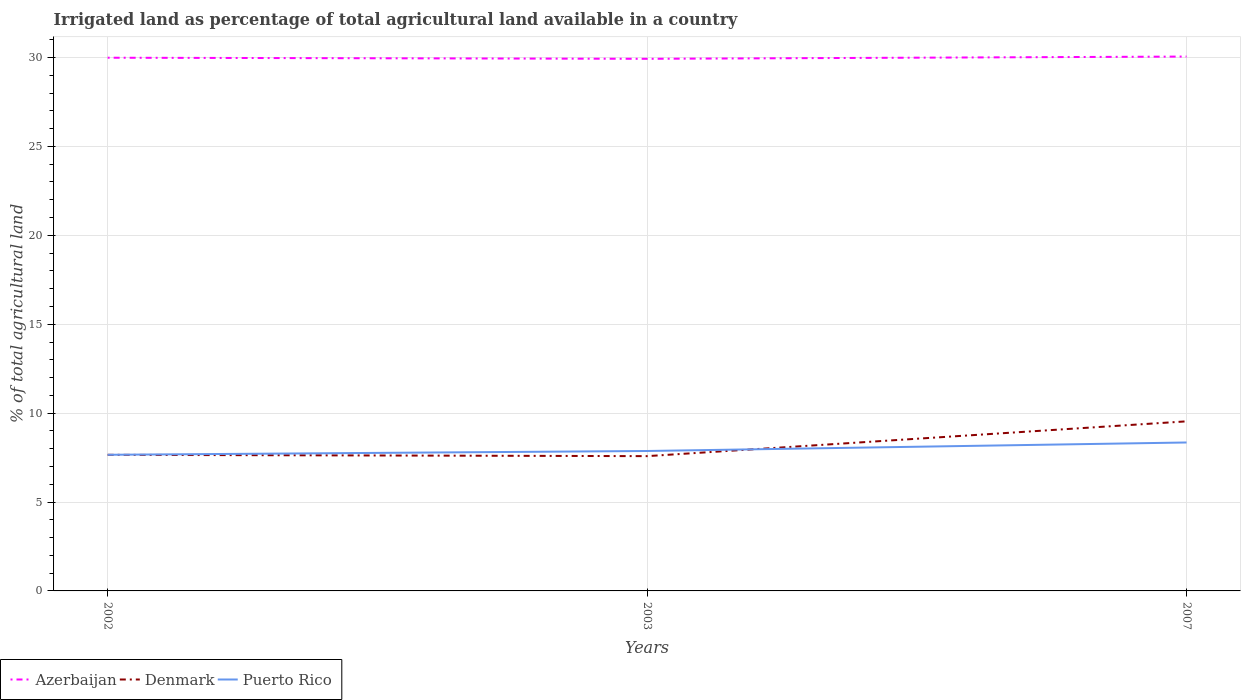Across all years, what is the maximum percentage of irrigated land in Denmark?
Provide a short and direct response. 7.58. In which year was the percentage of irrigated land in Denmark maximum?
Provide a short and direct response. 2003. What is the total percentage of irrigated land in Azerbaijan in the graph?
Provide a short and direct response. -0.13. What is the difference between the highest and the second highest percentage of irrigated land in Denmark?
Provide a succinct answer. 1.96. Are the values on the major ticks of Y-axis written in scientific E-notation?
Offer a very short reply. No. Does the graph contain any zero values?
Give a very brief answer. No. Does the graph contain grids?
Your response must be concise. Yes. Where does the legend appear in the graph?
Make the answer very short. Bottom left. How many legend labels are there?
Your response must be concise. 3. What is the title of the graph?
Make the answer very short. Irrigated land as percentage of total agricultural land available in a country. Does "St. Vincent and the Grenadines" appear as one of the legend labels in the graph?
Keep it short and to the point. No. What is the label or title of the X-axis?
Your answer should be compact. Years. What is the label or title of the Y-axis?
Keep it short and to the point. % of total agricultural land. What is the % of total agricultural land in Azerbaijan in 2002?
Provide a short and direct response. 29.99. What is the % of total agricultural land in Denmark in 2002?
Provide a succinct answer. 7.65. What is the % of total agricultural land in Puerto Rico in 2002?
Keep it short and to the point. 7.66. What is the % of total agricultural land in Azerbaijan in 2003?
Provide a succinct answer. 29.93. What is the % of total agricultural land in Denmark in 2003?
Provide a succinct answer. 7.58. What is the % of total agricultural land of Puerto Rico in 2003?
Keep it short and to the point. 7.87. What is the % of total agricultural land in Azerbaijan in 2007?
Provide a short and direct response. 30.06. What is the % of total agricultural land in Denmark in 2007?
Provide a short and direct response. 9.54. What is the % of total agricultural land in Puerto Rico in 2007?
Keep it short and to the point. 8.35. Across all years, what is the maximum % of total agricultural land in Azerbaijan?
Provide a succinct answer. 30.06. Across all years, what is the maximum % of total agricultural land in Denmark?
Your answer should be very brief. 9.54. Across all years, what is the maximum % of total agricultural land in Puerto Rico?
Provide a short and direct response. 8.35. Across all years, what is the minimum % of total agricultural land of Azerbaijan?
Offer a very short reply. 29.93. Across all years, what is the minimum % of total agricultural land of Denmark?
Keep it short and to the point. 7.58. Across all years, what is the minimum % of total agricultural land in Puerto Rico?
Your answer should be compact. 7.66. What is the total % of total agricultural land in Azerbaijan in the graph?
Keep it short and to the point. 89.97. What is the total % of total agricultural land in Denmark in the graph?
Offer a very short reply. 24.77. What is the total % of total agricultural land of Puerto Rico in the graph?
Provide a short and direct response. 23.88. What is the difference between the % of total agricultural land of Azerbaijan in 2002 and that in 2003?
Your answer should be very brief. 0.06. What is the difference between the % of total agricultural land of Denmark in 2002 and that in 2003?
Your answer should be very brief. 0.07. What is the difference between the % of total agricultural land of Puerto Rico in 2002 and that in 2003?
Offer a very short reply. -0.21. What is the difference between the % of total agricultural land of Azerbaijan in 2002 and that in 2007?
Provide a short and direct response. -0.07. What is the difference between the % of total agricultural land in Denmark in 2002 and that in 2007?
Make the answer very short. -1.88. What is the difference between the % of total agricultural land of Puerto Rico in 2002 and that in 2007?
Offer a terse response. -0.69. What is the difference between the % of total agricultural land in Azerbaijan in 2003 and that in 2007?
Ensure brevity in your answer.  -0.13. What is the difference between the % of total agricultural land in Denmark in 2003 and that in 2007?
Your answer should be very brief. -1.96. What is the difference between the % of total agricultural land of Puerto Rico in 2003 and that in 2007?
Provide a succinct answer. -0.48. What is the difference between the % of total agricultural land of Azerbaijan in 2002 and the % of total agricultural land of Denmark in 2003?
Provide a succinct answer. 22.41. What is the difference between the % of total agricultural land of Azerbaijan in 2002 and the % of total agricultural land of Puerto Rico in 2003?
Your answer should be very brief. 22.12. What is the difference between the % of total agricultural land of Denmark in 2002 and the % of total agricultural land of Puerto Rico in 2003?
Offer a terse response. -0.22. What is the difference between the % of total agricultural land in Azerbaijan in 2002 and the % of total agricultural land in Denmark in 2007?
Provide a succinct answer. 20.45. What is the difference between the % of total agricultural land of Azerbaijan in 2002 and the % of total agricultural land of Puerto Rico in 2007?
Provide a short and direct response. 21.64. What is the difference between the % of total agricultural land of Denmark in 2002 and the % of total agricultural land of Puerto Rico in 2007?
Your answer should be compact. -0.69. What is the difference between the % of total agricultural land of Azerbaijan in 2003 and the % of total agricultural land of Denmark in 2007?
Offer a very short reply. 20.39. What is the difference between the % of total agricultural land in Azerbaijan in 2003 and the % of total agricultural land in Puerto Rico in 2007?
Make the answer very short. 21.58. What is the difference between the % of total agricultural land in Denmark in 2003 and the % of total agricultural land in Puerto Rico in 2007?
Provide a short and direct response. -0.77. What is the average % of total agricultural land in Azerbaijan per year?
Keep it short and to the point. 29.99. What is the average % of total agricultural land in Denmark per year?
Keep it short and to the point. 8.26. What is the average % of total agricultural land in Puerto Rico per year?
Offer a terse response. 7.96. In the year 2002, what is the difference between the % of total agricultural land of Azerbaijan and % of total agricultural land of Denmark?
Your answer should be very brief. 22.34. In the year 2002, what is the difference between the % of total agricultural land of Azerbaijan and % of total agricultural land of Puerto Rico?
Provide a succinct answer. 22.33. In the year 2002, what is the difference between the % of total agricultural land in Denmark and % of total agricultural land in Puerto Rico?
Your response must be concise. -0. In the year 2003, what is the difference between the % of total agricultural land of Azerbaijan and % of total agricultural land of Denmark?
Offer a terse response. 22.35. In the year 2003, what is the difference between the % of total agricultural land of Azerbaijan and % of total agricultural land of Puerto Rico?
Keep it short and to the point. 22.06. In the year 2003, what is the difference between the % of total agricultural land of Denmark and % of total agricultural land of Puerto Rico?
Offer a very short reply. -0.29. In the year 2007, what is the difference between the % of total agricultural land in Azerbaijan and % of total agricultural land in Denmark?
Provide a short and direct response. 20.52. In the year 2007, what is the difference between the % of total agricultural land in Azerbaijan and % of total agricultural land in Puerto Rico?
Ensure brevity in your answer.  21.71. In the year 2007, what is the difference between the % of total agricultural land in Denmark and % of total agricultural land in Puerto Rico?
Your response must be concise. 1.19. What is the ratio of the % of total agricultural land of Denmark in 2002 to that in 2003?
Ensure brevity in your answer.  1.01. What is the ratio of the % of total agricultural land in Denmark in 2002 to that in 2007?
Provide a succinct answer. 0.8. What is the ratio of the % of total agricultural land of Puerto Rico in 2002 to that in 2007?
Give a very brief answer. 0.92. What is the ratio of the % of total agricultural land in Denmark in 2003 to that in 2007?
Give a very brief answer. 0.79. What is the ratio of the % of total agricultural land of Puerto Rico in 2003 to that in 2007?
Provide a succinct answer. 0.94. What is the difference between the highest and the second highest % of total agricultural land of Azerbaijan?
Your response must be concise. 0.07. What is the difference between the highest and the second highest % of total agricultural land of Denmark?
Make the answer very short. 1.88. What is the difference between the highest and the second highest % of total agricultural land of Puerto Rico?
Offer a very short reply. 0.48. What is the difference between the highest and the lowest % of total agricultural land in Azerbaijan?
Ensure brevity in your answer.  0.13. What is the difference between the highest and the lowest % of total agricultural land in Denmark?
Ensure brevity in your answer.  1.96. What is the difference between the highest and the lowest % of total agricultural land in Puerto Rico?
Keep it short and to the point. 0.69. 